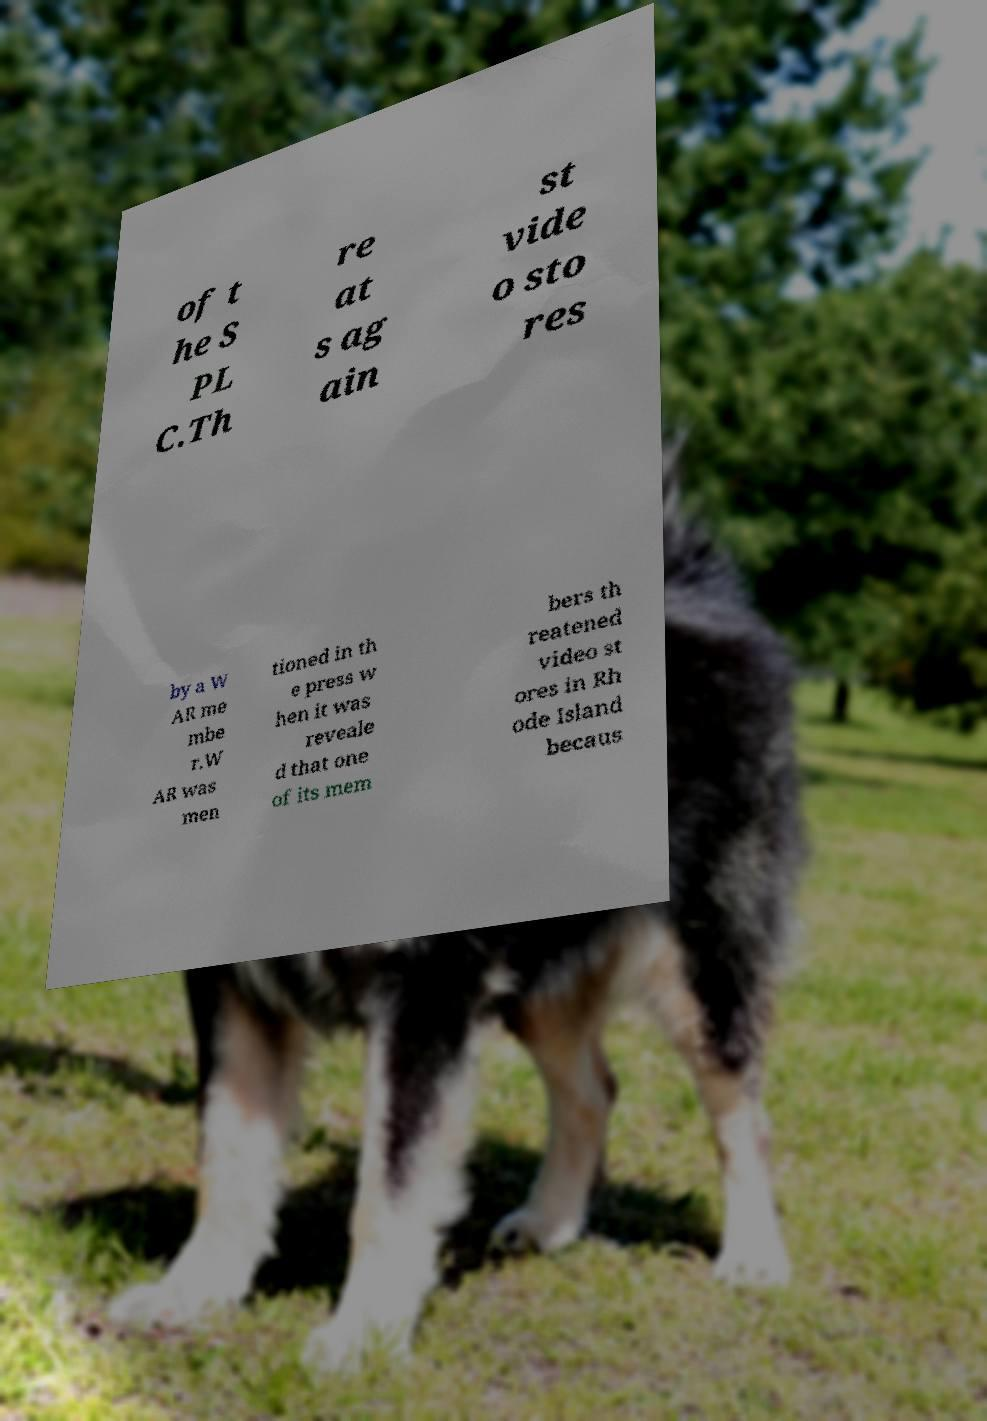Can you accurately transcribe the text from the provided image for me? of t he S PL C.Th re at s ag ain st vide o sto res by a W AR me mbe r.W AR was men tioned in th e press w hen it was reveale d that one of its mem bers th reatened video st ores in Rh ode Island becaus 